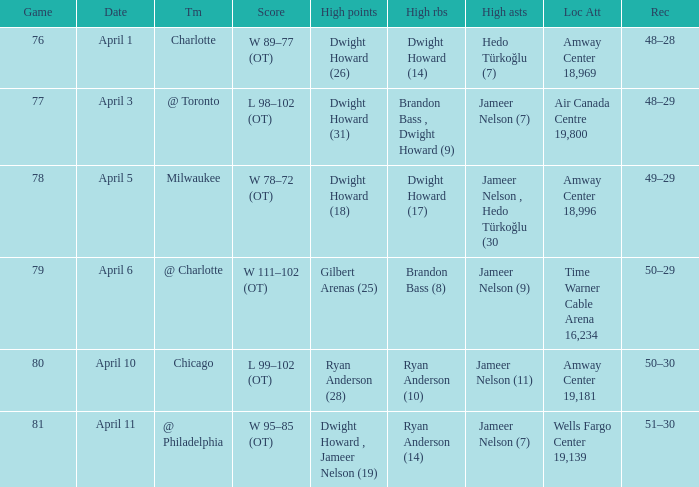Would you be able to parse every entry in this table? {'header': ['Game', 'Date', 'Tm', 'Score', 'High points', 'High rbs', 'High asts', 'Loc Att', 'Rec'], 'rows': [['76', 'April 1', 'Charlotte', 'W 89–77 (OT)', 'Dwight Howard (26)', 'Dwight Howard (14)', 'Hedo Türkoğlu (7)', 'Amway Center 18,969', '48–28'], ['77', 'April 3', '@ Toronto', 'L 98–102 (OT)', 'Dwight Howard (31)', 'Brandon Bass , Dwight Howard (9)', 'Jameer Nelson (7)', 'Air Canada Centre 19,800', '48–29'], ['78', 'April 5', 'Milwaukee', 'W 78–72 (OT)', 'Dwight Howard (18)', 'Dwight Howard (17)', 'Jameer Nelson , Hedo Türkoğlu (30', 'Amway Center 18,996', '49–29'], ['79', 'April 6', '@ Charlotte', 'W 111–102 (OT)', 'Gilbert Arenas (25)', 'Brandon Bass (8)', 'Jameer Nelson (9)', 'Time Warner Cable Arena 16,234', '50–29'], ['80', 'April 10', 'Chicago', 'L 99–102 (OT)', 'Ryan Anderson (28)', 'Ryan Anderson (10)', 'Jameer Nelson (11)', 'Amway Center 19,181', '50–30'], ['81', 'April 11', '@ Philadelphia', 'W 95–85 (OT)', 'Dwight Howard , Jameer Nelson (19)', 'Ryan Anderson (14)', 'Jameer Nelson (7)', 'Wells Fargo Center 19,139', '51–30']]} Where was the game and what was the attendance on April 3?  Air Canada Centre 19,800. 